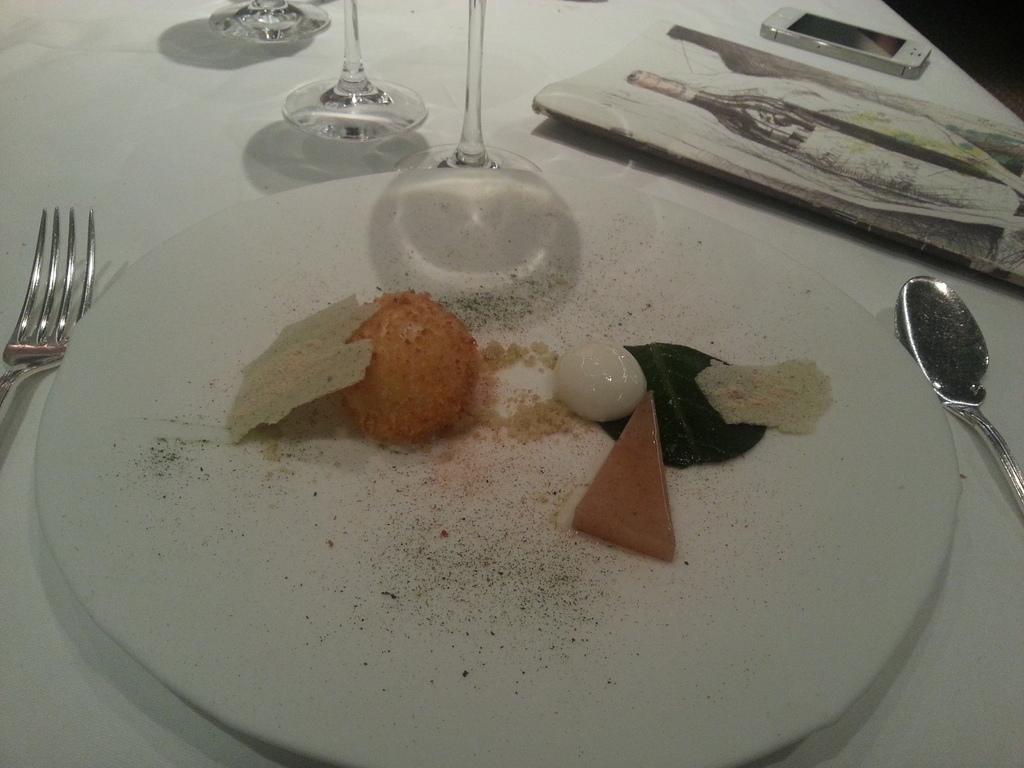How would you summarize this image in a sentence or two? The picture consists of glasses, fork, spoon, menu card, mobile and food served in a plate, these are placed on a table. 